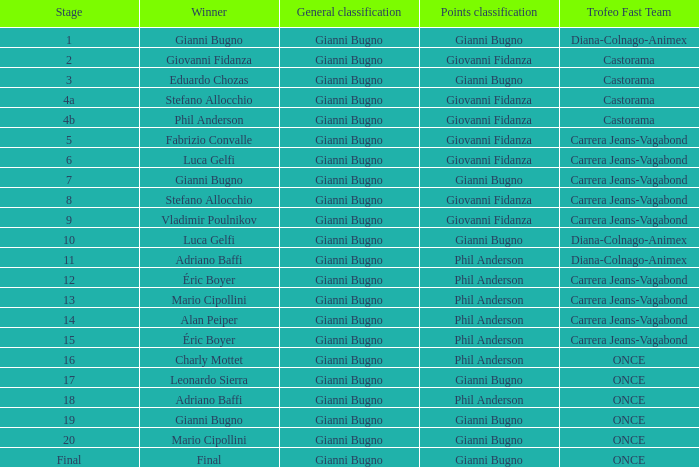What is the step when the conqueror is charly mottet? 16.0. 